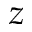<formula> <loc_0><loc_0><loc_500><loc_500>z</formula> 